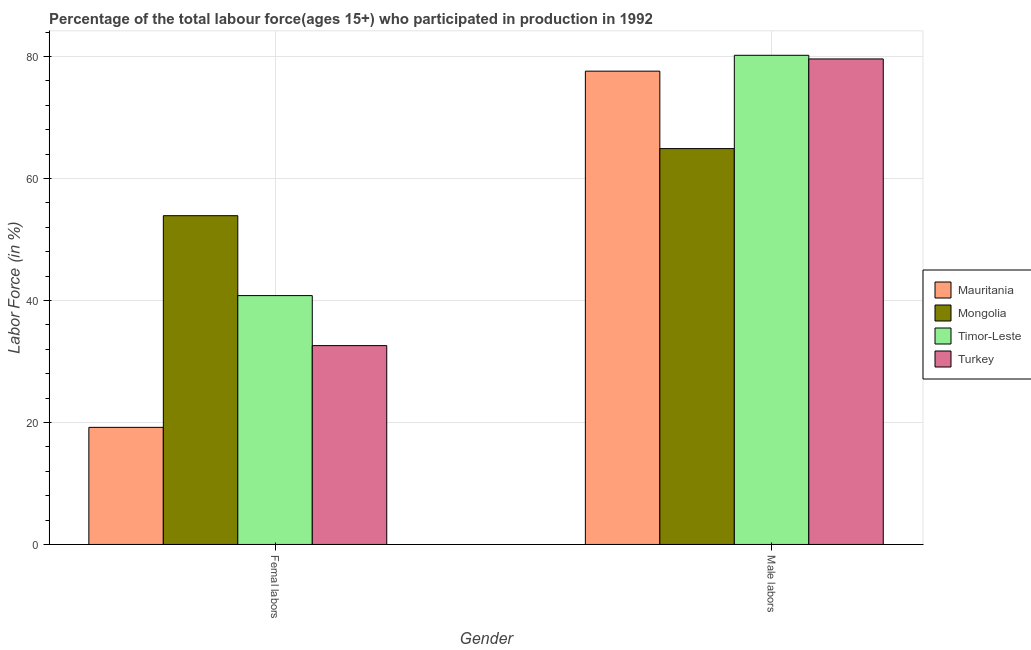How many different coloured bars are there?
Your answer should be very brief. 4. How many groups of bars are there?
Make the answer very short. 2. Are the number of bars on each tick of the X-axis equal?
Give a very brief answer. Yes. How many bars are there on the 1st tick from the left?
Keep it short and to the point. 4. What is the label of the 1st group of bars from the left?
Make the answer very short. Femal labors. What is the percentage of male labour force in Timor-Leste?
Offer a very short reply. 80.2. Across all countries, what is the maximum percentage of female labor force?
Provide a short and direct response. 53.9. Across all countries, what is the minimum percentage of male labour force?
Make the answer very short. 64.9. In which country was the percentage of female labor force maximum?
Offer a very short reply. Mongolia. In which country was the percentage of female labor force minimum?
Keep it short and to the point. Mauritania. What is the total percentage of female labor force in the graph?
Your answer should be very brief. 146.5. What is the difference between the percentage of female labor force in Turkey and that in Mongolia?
Keep it short and to the point. -21.3. What is the difference between the percentage of female labor force in Mauritania and the percentage of male labour force in Turkey?
Provide a succinct answer. -60.4. What is the average percentage of male labour force per country?
Make the answer very short. 75.57. What is the difference between the percentage of female labor force and percentage of male labour force in Mauritania?
Keep it short and to the point. -58.4. In how many countries, is the percentage of male labour force greater than 36 %?
Your response must be concise. 4. What is the ratio of the percentage of female labor force in Timor-Leste to that in Turkey?
Your response must be concise. 1.25. In how many countries, is the percentage of male labour force greater than the average percentage of male labour force taken over all countries?
Your answer should be very brief. 3. What does the 3rd bar from the left in Male labors represents?
Your answer should be compact. Timor-Leste. How many countries are there in the graph?
Your answer should be very brief. 4. What is the difference between two consecutive major ticks on the Y-axis?
Keep it short and to the point. 20. Does the graph contain grids?
Offer a terse response. Yes. Where does the legend appear in the graph?
Your answer should be compact. Center right. How many legend labels are there?
Give a very brief answer. 4. What is the title of the graph?
Offer a terse response. Percentage of the total labour force(ages 15+) who participated in production in 1992. What is the Labor Force (in %) of Mauritania in Femal labors?
Give a very brief answer. 19.2. What is the Labor Force (in %) in Mongolia in Femal labors?
Provide a short and direct response. 53.9. What is the Labor Force (in %) in Timor-Leste in Femal labors?
Provide a short and direct response. 40.8. What is the Labor Force (in %) of Turkey in Femal labors?
Ensure brevity in your answer.  32.6. What is the Labor Force (in %) in Mauritania in Male labors?
Provide a short and direct response. 77.6. What is the Labor Force (in %) of Mongolia in Male labors?
Your answer should be compact. 64.9. What is the Labor Force (in %) of Timor-Leste in Male labors?
Your answer should be compact. 80.2. What is the Labor Force (in %) of Turkey in Male labors?
Offer a very short reply. 79.6. Across all Gender, what is the maximum Labor Force (in %) in Mauritania?
Your answer should be very brief. 77.6. Across all Gender, what is the maximum Labor Force (in %) of Mongolia?
Give a very brief answer. 64.9. Across all Gender, what is the maximum Labor Force (in %) of Timor-Leste?
Ensure brevity in your answer.  80.2. Across all Gender, what is the maximum Labor Force (in %) in Turkey?
Your answer should be very brief. 79.6. Across all Gender, what is the minimum Labor Force (in %) in Mauritania?
Provide a succinct answer. 19.2. Across all Gender, what is the minimum Labor Force (in %) of Mongolia?
Your response must be concise. 53.9. Across all Gender, what is the minimum Labor Force (in %) of Timor-Leste?
Provide a succinct answer. 40.8. Across all Gender, what is the minimum Labor Force (in %) in Turkey?
Your answer should be very brief. 32.6. What is the total Labor Force (in %) in Mauritania in the graph?
Offer a terse response. 96.8. What is the total Labor Force (in %) of Mongolia in the graph?
Make the answer very short. 118.8. What is the total Labor Force (in %) in Timor-Leste in the graph?
Your answer should be very brief. 121. What is the total Labor Force (in %) of Turkey in the graph?
Make the answer very short. 112.2. What is the difference between the Labor Force (in %) in Mauritania in Femal labors and that in Male labors?
Give a very brief answer. -58.4. What is the difference between the Labor Force (in %) in Mongolia in Femal labors and that in Male labors?
Ensure brevity in your answer.  -11. What is the difference between the Labor Force (in %) in Timor-Leste in Femal labors and that in Male labors?
Your response must be concise. -39.4. What is the difference between the Labor Force (in %) in Turkey in Femal labors and that in Male labors?
Offer a terse response. -47. What is the difference between the Labor Force (in %) of Mauritania in Femal labors and the Labor Force (in %) of Mongolia in Male labors?
Give a very brief answer. -45.7. What is the difference between the Labor Force (in %) of Mauritania in Femal labors and the Labor Force (in %) of Timor-Leste in Male labors?
Offer a terse response. -61. What is the difference between the Labor Force (in %) of Mauritania in Femal labors and the Labor Force (in %) of Turkey in Male labors?
Your response must be concise. -60.4. What is the difference between the Labor Force (in %) in Mongolia in Femal labors and the Labor Force (in %) in Timor-Leste in Male labors?
Your response must be concise. -26.3. What is the difference between the Labor Force (in %) in Mongolia in Femal labors and the Labor Force (in %) in Turkey in Male labors?
Your response must be concise. -25.7. What is the difference between the Labor Force (in %) in Timor-Leste in Femal labors and the Labor Force (in %) in Turkey in Male labors?
Make the answer very short. -38.8. What is the average Labor Force (in %) of Mauritania per Gender?
Give a very brief answer. 48.4. What is the average Labor Force (in %) in Mongolia per Gender?
Provide a short and direct response. 59.4. What is the average Labor Force (in %) of Timor-Leste per Gender?
Provide a short and direct response. 60.5. What is the average Labor Force (in %) of Turkey per Gender?
Your answer should be compact. 56.1. What is the difference between the Labor Force (in %) of Mauritania and Labor Force (in %) of Mongolia in Femal labors?
Your answer should be compact. -34.7. What is the difference between the Labor Force (in %) of Mauritania and Labor Force (in %) of Timor-Leste in Femal labors?
Your response must be concise. -21.6. What is the difference between the Labor Force (in %) of Mongolia and Labor Force (in %) of Timor-Leste in Femal labors?
Offer a terse response. 13.1. What is the difference between the Labor Force (in %) of Mongolia and Labor Force (in %) of Turkey in Femal labors?
Your response must be concise. 21.3. What is the difference between the Labor Force (in %) of Timor-Leste and Labor Force (in %) of Turkey in Femal labors?
Make the answer very short. 8.2. What is the difference between the Labor Force (in %) in Mauritania and Labor Force (in %) in Mongolia in Male labors?
Your response must be concise. 12.7. What is the difference between the Labor Force (in %) of Mauritania and Labor Force (in %) of Timor-Leste in Male labors?
Your answer should be compact. -2.6. What is the difference between the Labor Force (in %) in Mongolia and Labor Force (in %) in Timor-Leste in Male labors?
Your response must be concise. -15.3. What is the difference between the Labor Force (in %) in Mongolia and Labor Force (in %) in Turkey in Male labors?
Your answer should be very brief. -14.7. What is the difference between the Labor Force (in %) in Timor-Leste and Labor Force (in %) in Turkey in Male labors?
Ensure brevity in your answer.  0.6. What is the ratio of the Labor Force (in %) of Mauritania in Femal labors to that in Male labors?
Give a very brief answer. 0.25. What is the ratio of the Labor Force (in %) of Mongolia in Femal labors to that in Male labors?
Offer a terse response. 0.83. What is the ratio of the Labor Force (in %) in Timor-Leste in Femal labors to that in Male labors?
Your response must be concise. 0.51. What is the ratio of the Labor Force (in %) of Turkey in Femal labors to that in Male labors?
Offer a terse response. 0.41. What is the difference between the highest and the second highest Labor Force (in %) in Mauritania?
Your answer should be very brief. 58.4. What is the difference between the highest and the second highest Labor Force (in %) of Timor-Leste?
Provide a short and direct response. 39.4. What is the difference between the highest and the lowest Labor Force (in %) in Mauritania?
Give a very brief answer. 58.4. What is the difference between the highest and the lowest Labor Force (in %) of Mongolia?
Make the answer very short. 11. What is the difference between the highest and the lowest Labor Force (in %) of Timor-Leste?
Ensure brevity in your answer.  39.4. What is the difference between the highest and the lowest Labor Force (in %) of Turkey?
Make the answer very short. 47. 